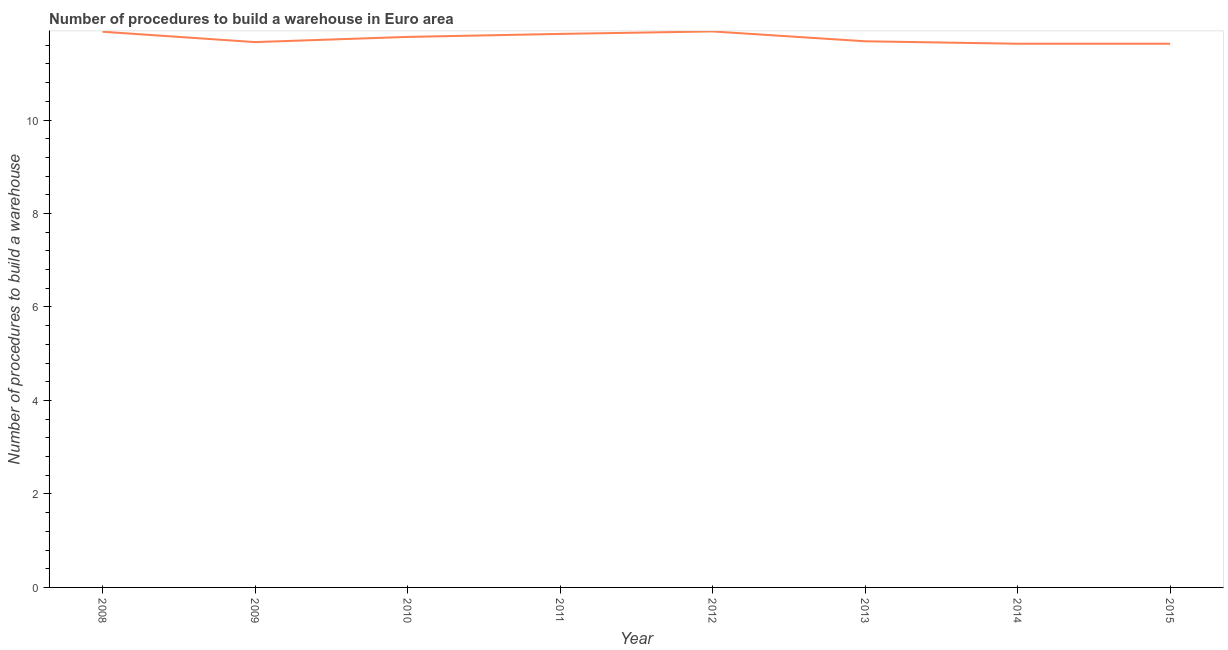What is the number of procedures to build a warehouse in 2013?
Provide a succinct answer. 11.68. Across all years, what is the maximum number of procedures to build a warehouse?
Keep it short and to the point. 11.89. Across all years, what is the minimum number of procedures to build a warehouse?
Give a very brief answer. 11.63. What is the sum of the number of procedures to build a warehouse?
Your answer should be very brief. 94.02. What is the difference between the number of procedures to build a warehouse in 2010 and 2014?
Provide a short and direct response. 0.15. What is the average number of procedures to build a warehouse per year?
Ensure brevity in your answer.  11.75. What is the median number of procedures to build a warehouse?
Your answer should be compact. 11.73. Do a majority of the years between 2012 and 2014 (inclusive) have number of procedures to build a warehouse greater than 3.6 ?
Offer a very short reply. Yes. What is the ratio of the number of procedures to build a warehouse in 2012 to that in 2013?
Keep it short and to the point. 1.02. What is the difference between the highest and the second highest number of procedures to build a warehouse?
Ensure brevity in your answer.  0.01. Is the sum of the number of procedures to build a warehouse in 2014 and 2015 greater than the maximum number of procedures to build a warehouse across all years?
Your response must be concise. Yes. What is the difference between the highest and the lowest number of procedures to build a warehouse?
Give a very brief answer. 0.26. In how many years, is the number of procedures to build a warehouse greater than the average number of procedures to build a warehouse taken over all years?
Your answer should be very brief. 4. Does the graph contain any zero values?
Ensure brevity in your answer.  No. Does the graph contain grids?
Ensure brevity in your answer.  No. What is the title of the graph?
Your answer should be very brief. Number of procedures to build a warehouse in Euro area. What is the label or title of the Y-axis?
Offer a very short reply. Number of procedures to build a warehouse. What is the Number of procedures to build a warehouse in 2008?
Your answer should be compact. 11.89. What is the Number of procedures to build a warehouse of 2009?
Keep it short and to the point. 11.67. What is the Number of procedures to build a warehouse of 2010?
Provide a short and direct response. 11.78. What is the Number of procedures to build a warehouse of 2011?
Your answer should be very brief. 11.84. What is the Number of procedures to build a warehouse in 2012?
Your answer should be very brief. 11.89. What is the Number of procedures to build a warehouse in 2013?
Offer a very short reply. 11.68. What is the Number of procedures to build a warehouse in 2014?
Provide a succinct answer. 11.63. What is the Number of procedures to build a warehouse in 2015?
Your response must be concise. 11.63. What is the difference between the Number of procedures to build a warehouse in 2008 and 2009?
Ensure brevity in your answer.  0.22. What is the difference between the Number of procedures to build a warehouse in 2008 and 2010?
Offer a very short reply. 0.11. What is the difference between the Number of procedures to build a warehouse in 2008 and 2011?
Provide a succinct answer. 0.05. What is the difference between the Number of procedures to build a warehouse in 2008 and 2012?
Provide a short and direct response. -0.01. What is the difference between the Number of procedures to build a warehouse in 2008 and 2013?
Your answer should be very brief. 0.2. What is the difference between the Number of procedures to build a warehouse in 2008 and 2014?
Your answer should be compact. 0.26. What is the difference between the Number of procedures to build a warehouse in 2008 and 2015?
Provide a succinct answer. 0.26. What is the difference between the Number of procedures to build a warehouse in 2009 and 2010?
Your answer should be compact. -0.11. What is the difference between the Number of procedures to build a warehouse in 2009 and 2011?
Make the answer very short. -0.18. What is the difference between the Number of procedures to build a warehouse in 2009 and 2012?
Offer a terse response. -0.23. What is the difference between the Number of procedures to build a warehouse in 2009 and 2013?
Offer a terse response. -0.02. What is the difference between the Number of procedures to build a warehouse in 2009 and 2014?
Your answer should be compact. 0.04. What is the difference between the Number of procedures to build a warehouse in 2009 and 2015?
Provide a short and direct response. 0.04. What is the difference between the Number of procedures to build a warehouse in 2010 and 2011?
Offer a very short reply. -0.06. What is the difference between the Number of procedures to build a warehouse in 2010 and 2012?
Keep it short and to the point. -0.12. What is the difference between the Number of procedures to build a warehouse in 2010 and 2013?
Give a very brief answer. 0.09. What is the difference between the Number of procedures to build a warehouse in 2010 and 2014?
Give a very brief answer. 0.15. What is the difference between the Number of procedures to build a warehouse in 2010 and 2015?
Keep it short and to the point. 0.15. What is the difference between the Number of procedures to build a warehouse in 2011 and 2012?
Keep it short and to the point. -0.05. What is the difference between the Number of procedures to build a warehouse in 2011 and 2013?
Your answer should be very brief. 0.16. What is the difference between the Number of procedures to build a warehouse in 2011 and 2014?
Your response must be concise. 0.21. What is the difference between the Number of procedures to build a warehouse in 2011 and 2015?
Ensure brevity in your answer.  0.21. What is the difference between the Number of procedures to build a warehouse in 2012 and 2013?
Provide a succinct answer. 0.21. What is the difference between the Number of procedures to build a warehouse in 2012 and 2014?
Ensure brevity in your answer.  0.26. What is the difference between the Number of procedures to build a warehouse in 2012 and 2015?
Your answer should be compact. 0.26. What is the difference between the Number of procedures to build a warehouse in 2013 and 2014?
Your response must be concise. 0.05. What is the difference between the Number of procedures to build a warehouse in 2013 and 2015?
Offer a terse response. 0.05. What is the ratio of the Number of procedures to build a warehouse in 2008 to that in 2011?
Provide a succinct answer. 1. What is the ratio of the Number of procedures to build a warehouse in 2008 to that in 2013?
Ensure brevity in your answer.  1.02. What is the ratio of the Number of procedures to build a warehouse in 2008 to that in 2014?
Ensure brevity in your answer.  1.02. What is the ratio of the Number of procedures to build a warehouse in 2008 to that in 2015?
Offer a very short reply. 1.02. What is the ratio of the Number of procedures to build a warehouse in 2009 to that in 2010?
Keep it short and to the point. 0.99. What is the ratio of the Number of procedures to build a warehouse in 2009 to that in 2011?
Make the answer very short. 0.98. What is the ratio of the Number of procedures to build a warehouse in 2010 to that in 2012?
Keep it short and to the point. 0.99. What is the ratio of the Number of procedures to build a warehouse in 2010 to that in 2013?
Your answer should be very brief. 1.01. What is the ratio of the Number of procedures to build a warehouse in 2010 to that in 2015?
Give a very brief answer. 1.01. What is the ratio of the Number of procedures to build a warehouse in 2011 to that in 2013?
Give a very brief answer. 1.01. What is the ratio of the Number of procedures to build a warehouse in 2012 to that in 2015?
Provide a succinct answer. 1.02. What is the ratio of the Number of procedures to build a warehouse in 2013 to that in 2014?
Offer a terse response. 1. What is the ratio of the Number of procedures to build a warehouse in 2014 to that in 2015?
Keep it short and to the point. 1. 